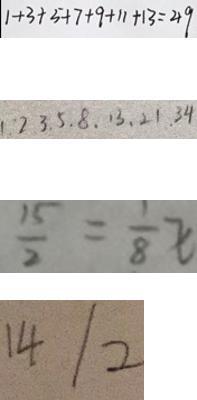<formula> <loc_0><loc_0><loc_500><loc_500>1 + 3 + 5 + 7 + 9 + 1 1 + 1 3 = 4 9 
 1 . 2 . 3 . 5 . 8 . 1 3 . 2 1 . 3 4 
 \frac { 1 5 } { 2 } = \frac { 1 } { 8 } x 
 1 4 / 2</formula> 